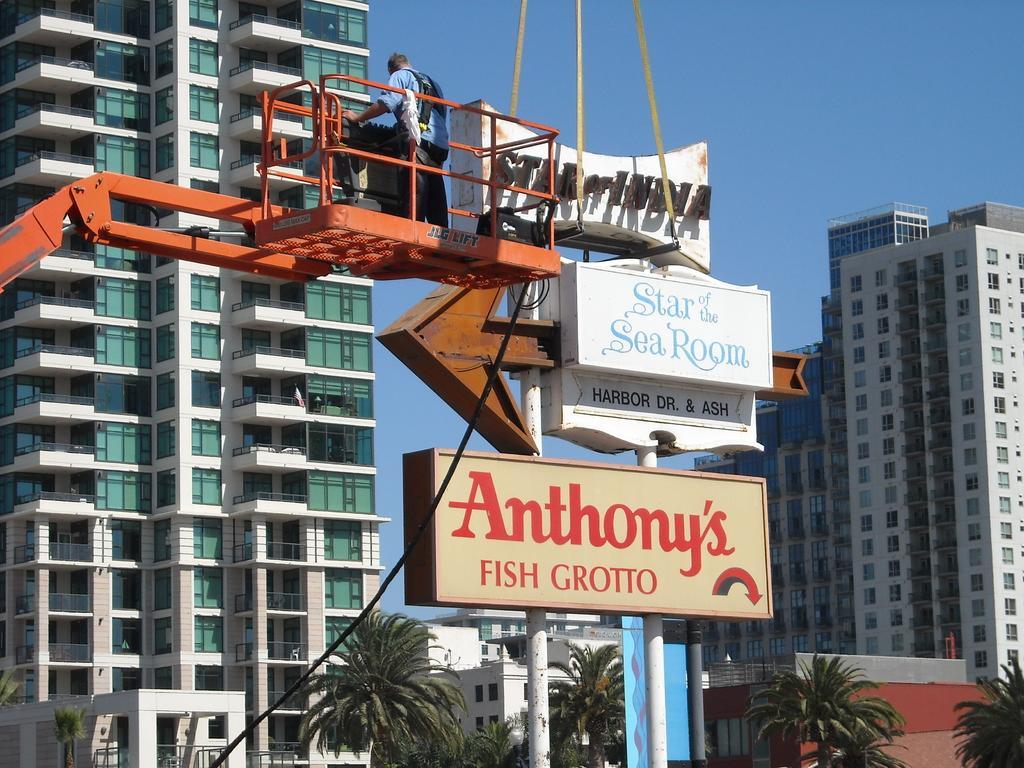Could you give a brief overview of what you see in this image? In this image I can see at the bottom there are trees, in the middle it looks like there are hoardings. On the left side it looks like there is the crane, a man is standing on it. At the back side there are buildings, at the top it is the sky. 